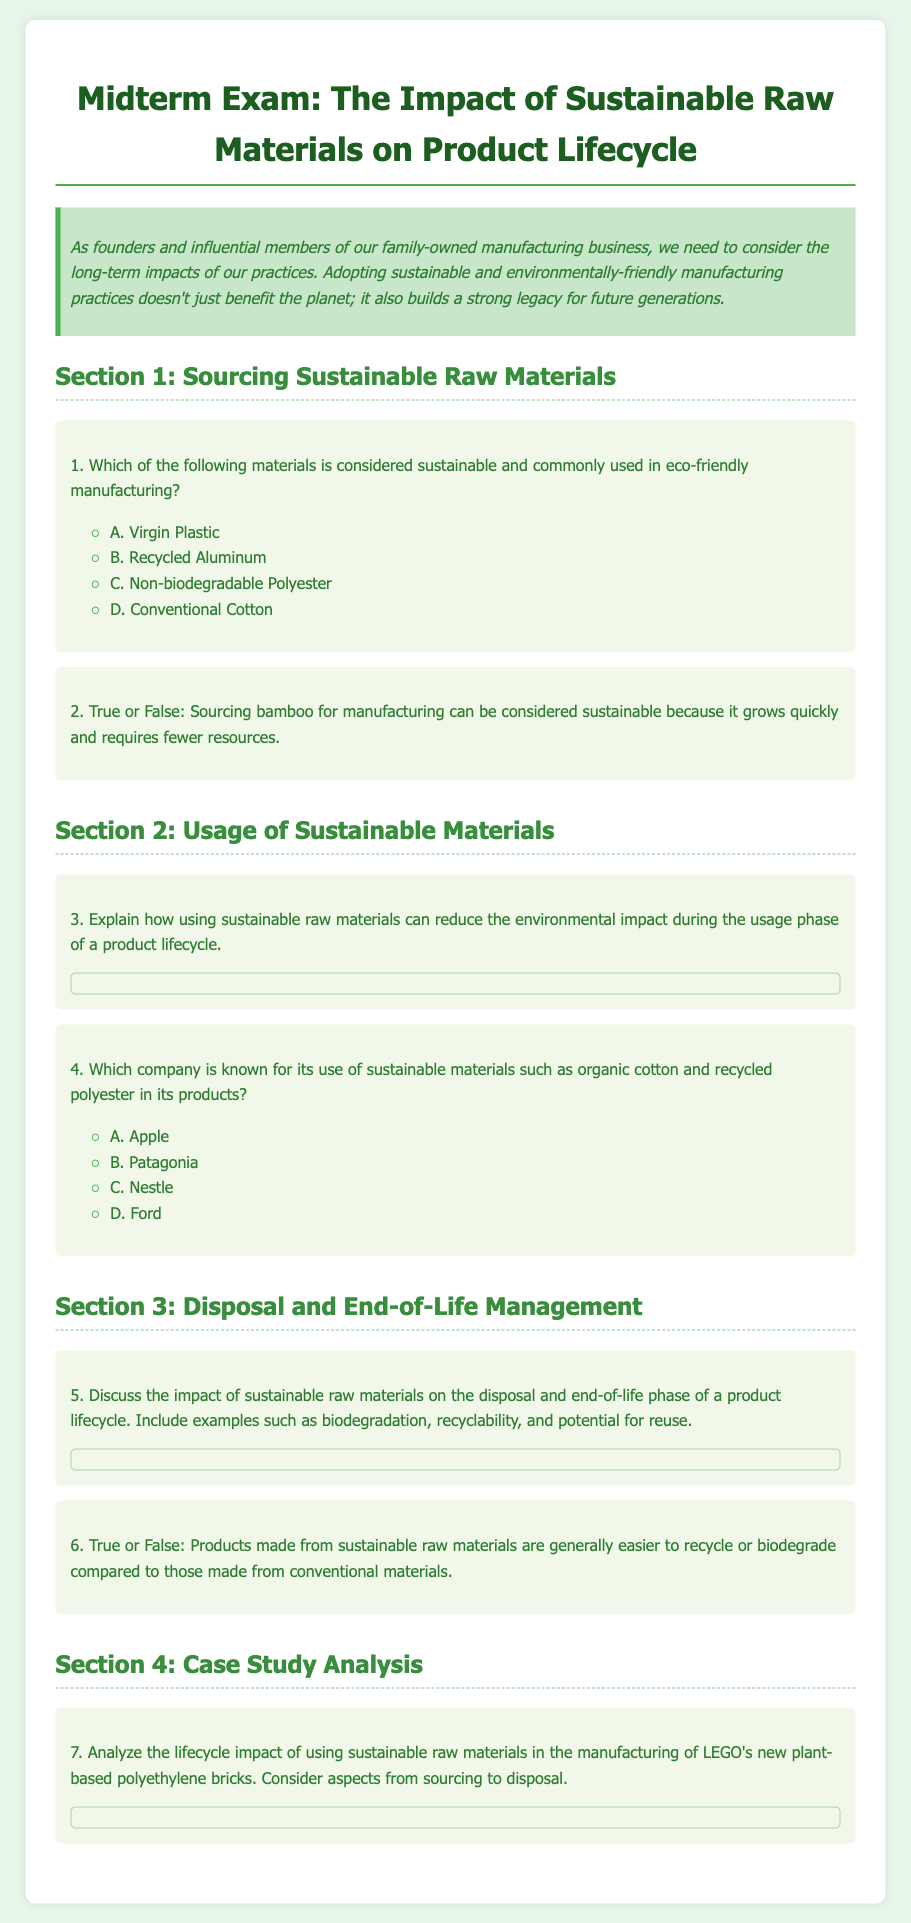What is the title of the exam? The title of the exam is stated at the top of the document, which outlines the focus on sustainable raw materials and their impact.
Answer: Midterm Exam: The Impact of Sustainable Raw Materials on Product Lifecycle What color is used for the background of the document? The background color of the document is specified in the CSS styles as a shade of green.
Answer: #e8f5e9 Which company is mentioned as known for using sustainable materials? The question specifically asks about a company associated with sustainable materials, which is explicitly listed in the options.
Answer: Patagonia What is a sustainable material that is often sourced for manufacturing? The document discusses various sustainable materials, highlighting specific examples. The answer is a common sustainable choice.
Answer: Bamboo What type of question is number 5 in the exam? The type of question is indicated clearly within the structure of the exam, specifying what kind of response is expected.
Answer: Essay 